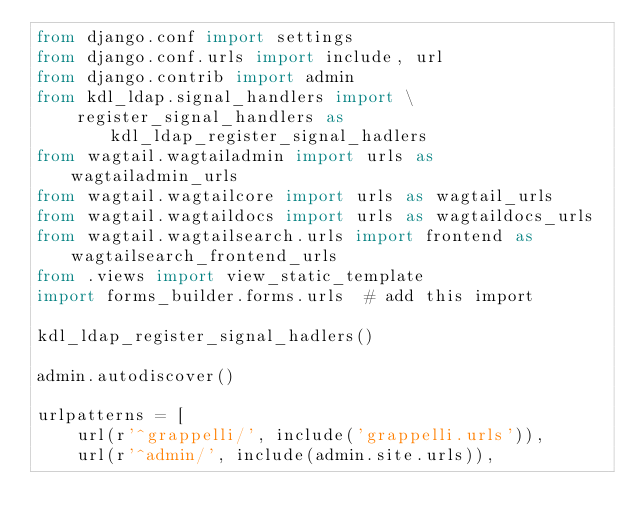<code> <loc_0><loc_0><loc_500><loc_500><_Python_>from django.conf import settings
from django.conf.urls import include, url
from django.contrib import admin
from kdl_ldap.signal_handlers import \
    register_signal_handlers as kdl_ldap_register_signal_hadlers
from wagtail.wagtailadmin import urls as wagtailadmin_urls
from wagtail.wagtailcore import urls as wagtail_urls
from wagtail.wagtaildocs import urls as wagtaildocs_urls
from wagtail.wagtailsearch.urls import frontend as wagtailsearch_frontend_urls
from .views import view_static_template
import forms_builder.forms.urls  # add this import

kdl_ldap_register_signal_hadlers()

admin.autodiscover()

urlpatterns = [
    url(r'^grappelli/', include('grappelli.urls')),
    url(r'^admin/', include(admin.site.urls)),
</code> 